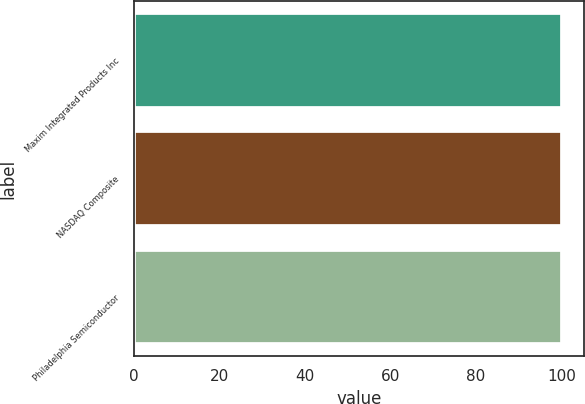<chart> <loc_0><loc_0><loc_500><loc_500><bar_chart><fcel>Maxim Integrated Products Inc<fcel>NASDAQ Composite<fcel>Philadelphia Semiconductor<nl><fcel>100<fcel>100.1<fcel>100.2<nl></chart> 